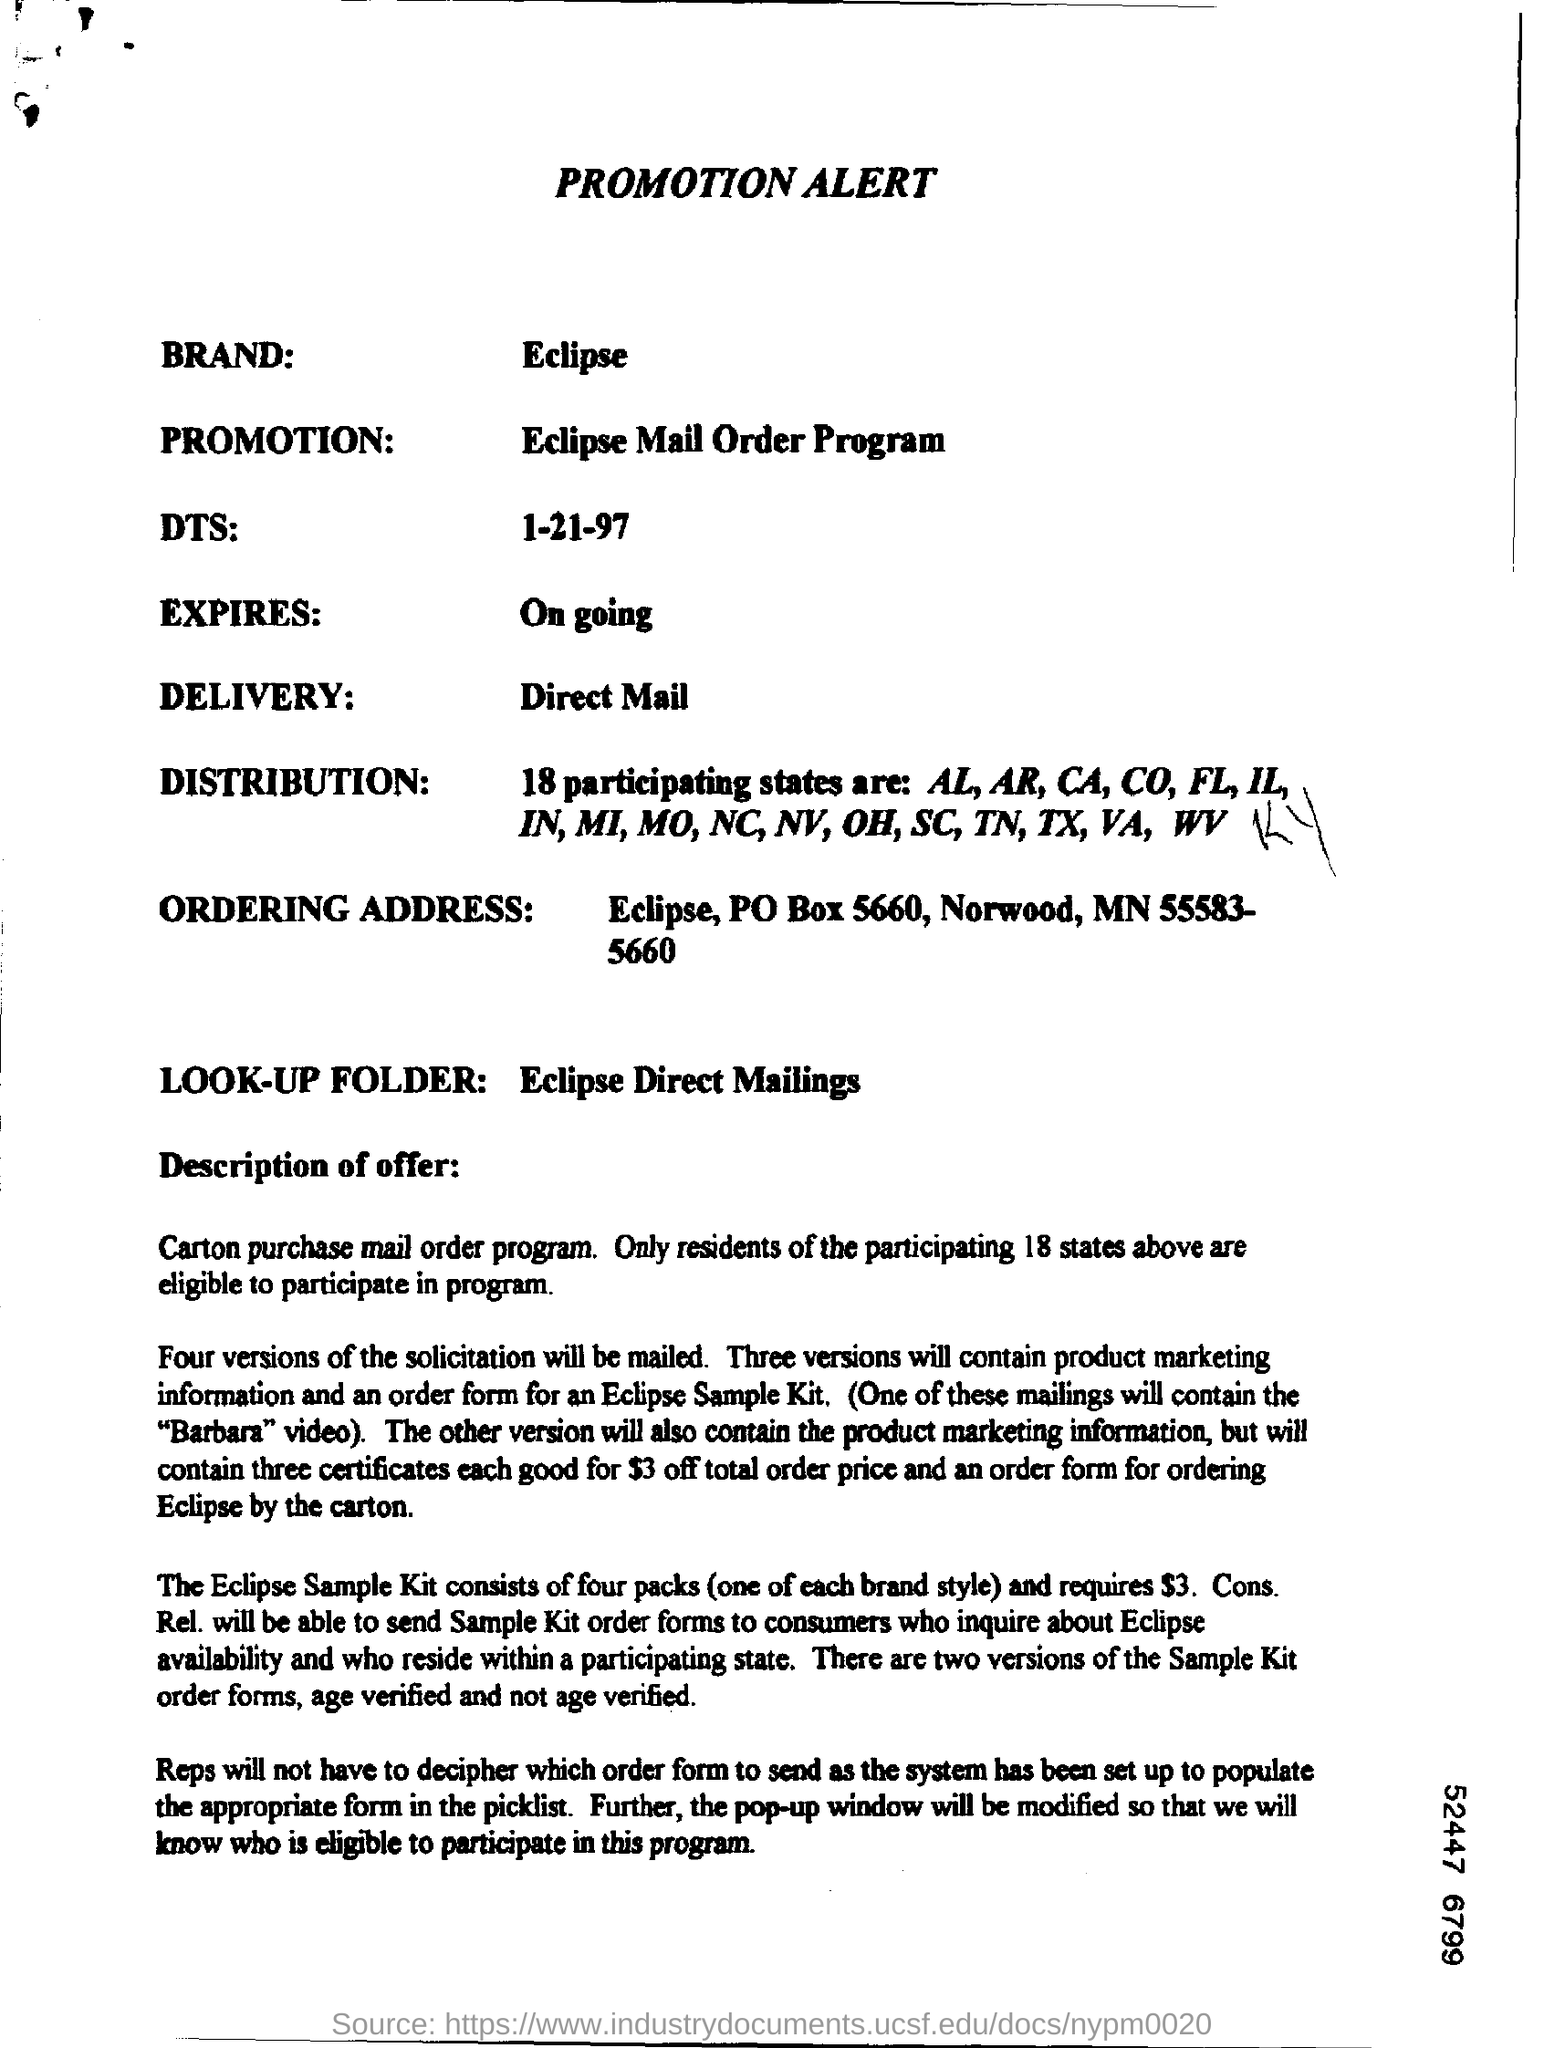What is the Brand?
Keep it short and to the point. Eclipse. What is the Promotion?
Your response must be concise. Eclipse mail order program. What is the DTS?
Make the answer very short. 1-21-97. What is the Delivery?
Offer a terse response. Direct mail. 